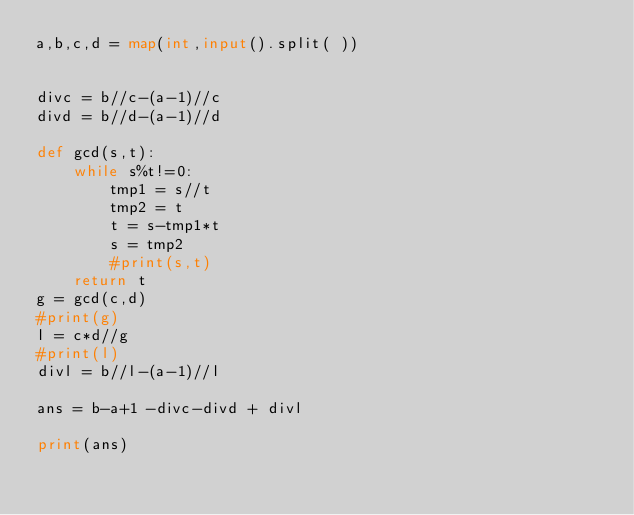Convert code to text. <code><loc_0><loc_0><loc_500><loc_500><_Python_>a,b,c,d = map(int,input().split( ))


divc = b//c-(a-1)//c
divd = b//d-(a-1)//d

def gcd(s,t):
    while s%t!=0:
        tmp1 = s//t
        tmp2 = t
        t = s-tmp1*t
        s = tmp2
        #print(s,t)
    return t
g = gcd(c,d)
#print(g)
l = c*d//g
#print(l)
divl = b//l-(a-1)//l

ans = b-a+1 -divc-divd + divl

print(ans)


</code> 